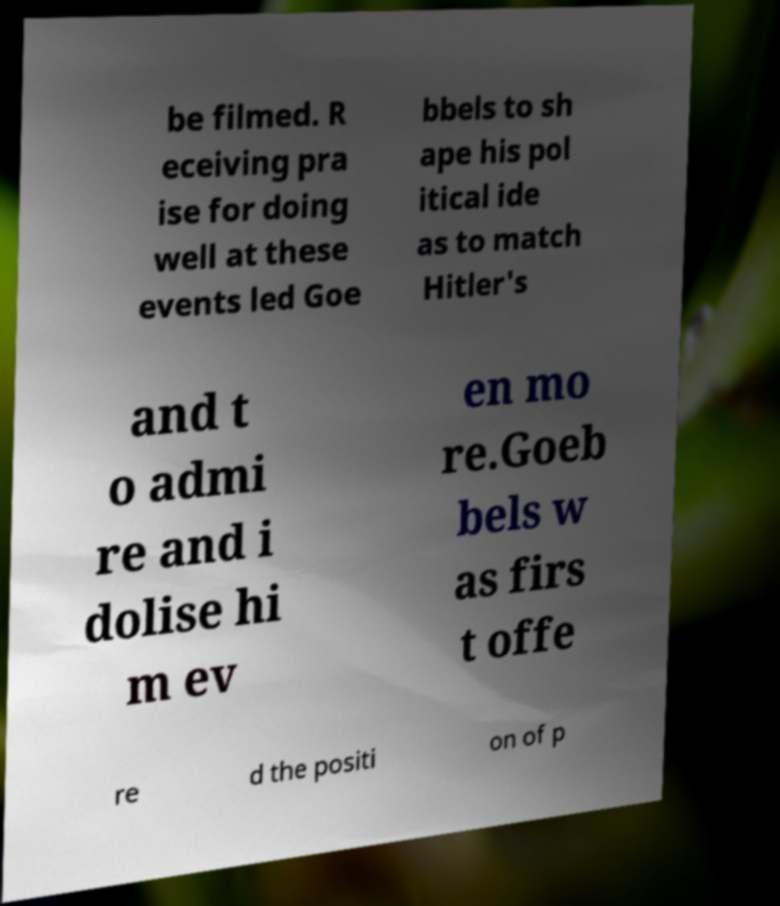What messages or text are displayed in this image? I need them in a readable, typed format. be filmed. R eceiving pra ise for doing well at these events led Goe bbels to sh ape his pol itical ide as to match Hitler's and t o admi re and i dolise hi m ev en mo re.Goeb bels w as firs t offe re d the positi on of p 